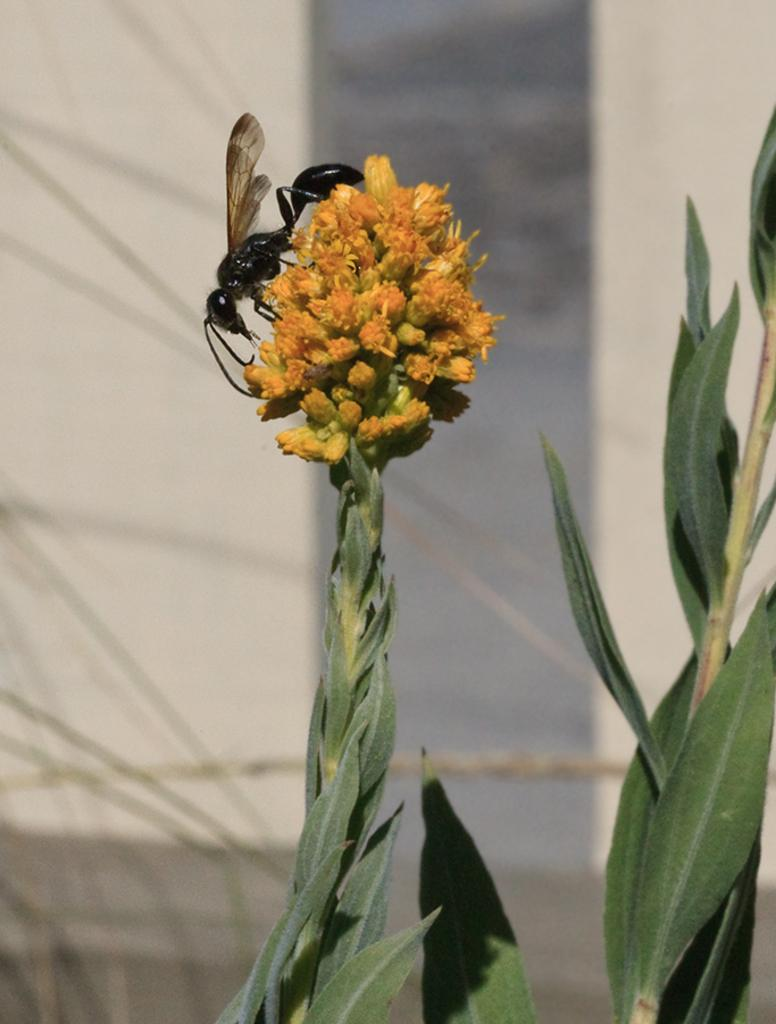What type of flower plant is in the image? There is a yellow color flower plant in the image. Where is the flower plant located in the image? The flower plant is in the front of the image. What else can be seen in the image besides the flower plant? There is a black color ant in the image, and it is on the top of the flower plant. What color are the leaves of the flower plant? The leaves in the image are green. How would you describe the background of the image? The background of the image is blurred. What type of rice is being cooked in the image? There is no rice present in the image; it features a yellow color flower plant with a black color ant on top. Can you see a rail in the image? There is no rail present in the image. 